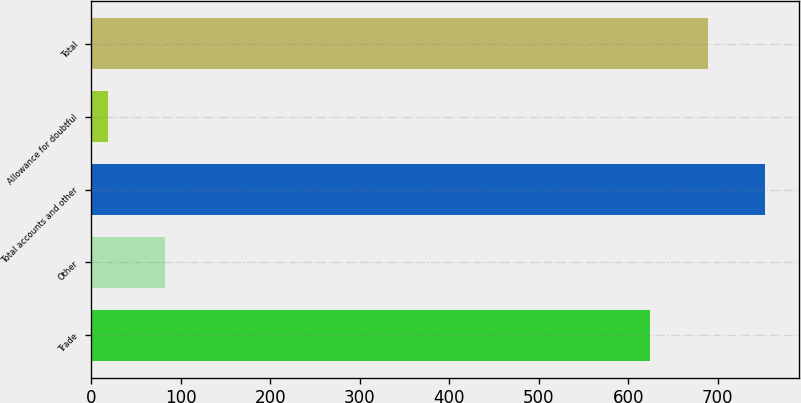Convert chart to OTSL. <chart><loc_0><loc_0><loc_500><loc_500><bar_chart><fcel>Trade<fcel>Other<fcel>Total accounts and other<fcel>Allowance for doubtful<fcel>Total<nl><fcel>624.7<fcel>82.22<fcel>752.74<fcel>18.2<fcel>688.72<nl></chart> 